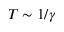Convert formula to latex. <formula><loc_0><loc_0><loc_500><loc_500>T \sim 1 / \gamma</formula> 